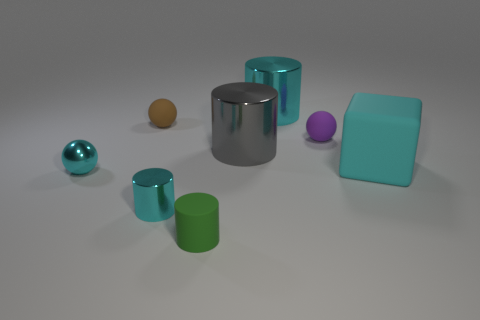Is the shiny ball the same color as the big matte thing?
Your answer should be very brief. Yes. Is the number of tiny brown things that are behind the purple ball greater than the number of brown matte balls that are right of the small cyan cylinder?
Your answer should be compact. Yes. Do the green cylinder and the small sphere to the right of the brown thing have the same material?
Provide a succinct answer. Yes. What is the color of the rubber block?
Make the answer very short. Cyan. The cyan thing behind the small purple thing has what shape?
Give a very brief answer. Cylinder. How many gray objects are either balls or cylinders?
Ensure brevity in your answer.  1. There is another large object that is made of the same material as the big gray thing; what color is it?
Ensure brevity in your answer.  Cyan. Is the color of the tiny metal ball the same as the shiny cylinder in front of the matte block?
Keep it short and to the point. Yes. There is a rubber object that is both on the left side of the large cyan matte block and right of the green matte cylinder; what color is it?
Offer a very short reply. Purple. There is a green rubber object; what number of shiny things are on the left side of it?
Your answer should be compact. 2. 